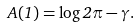<formula> <loc_0><loc_0><loc_500><loc_500>A ( 1 ) = \log 2 \pi - \gamma .</formula> 